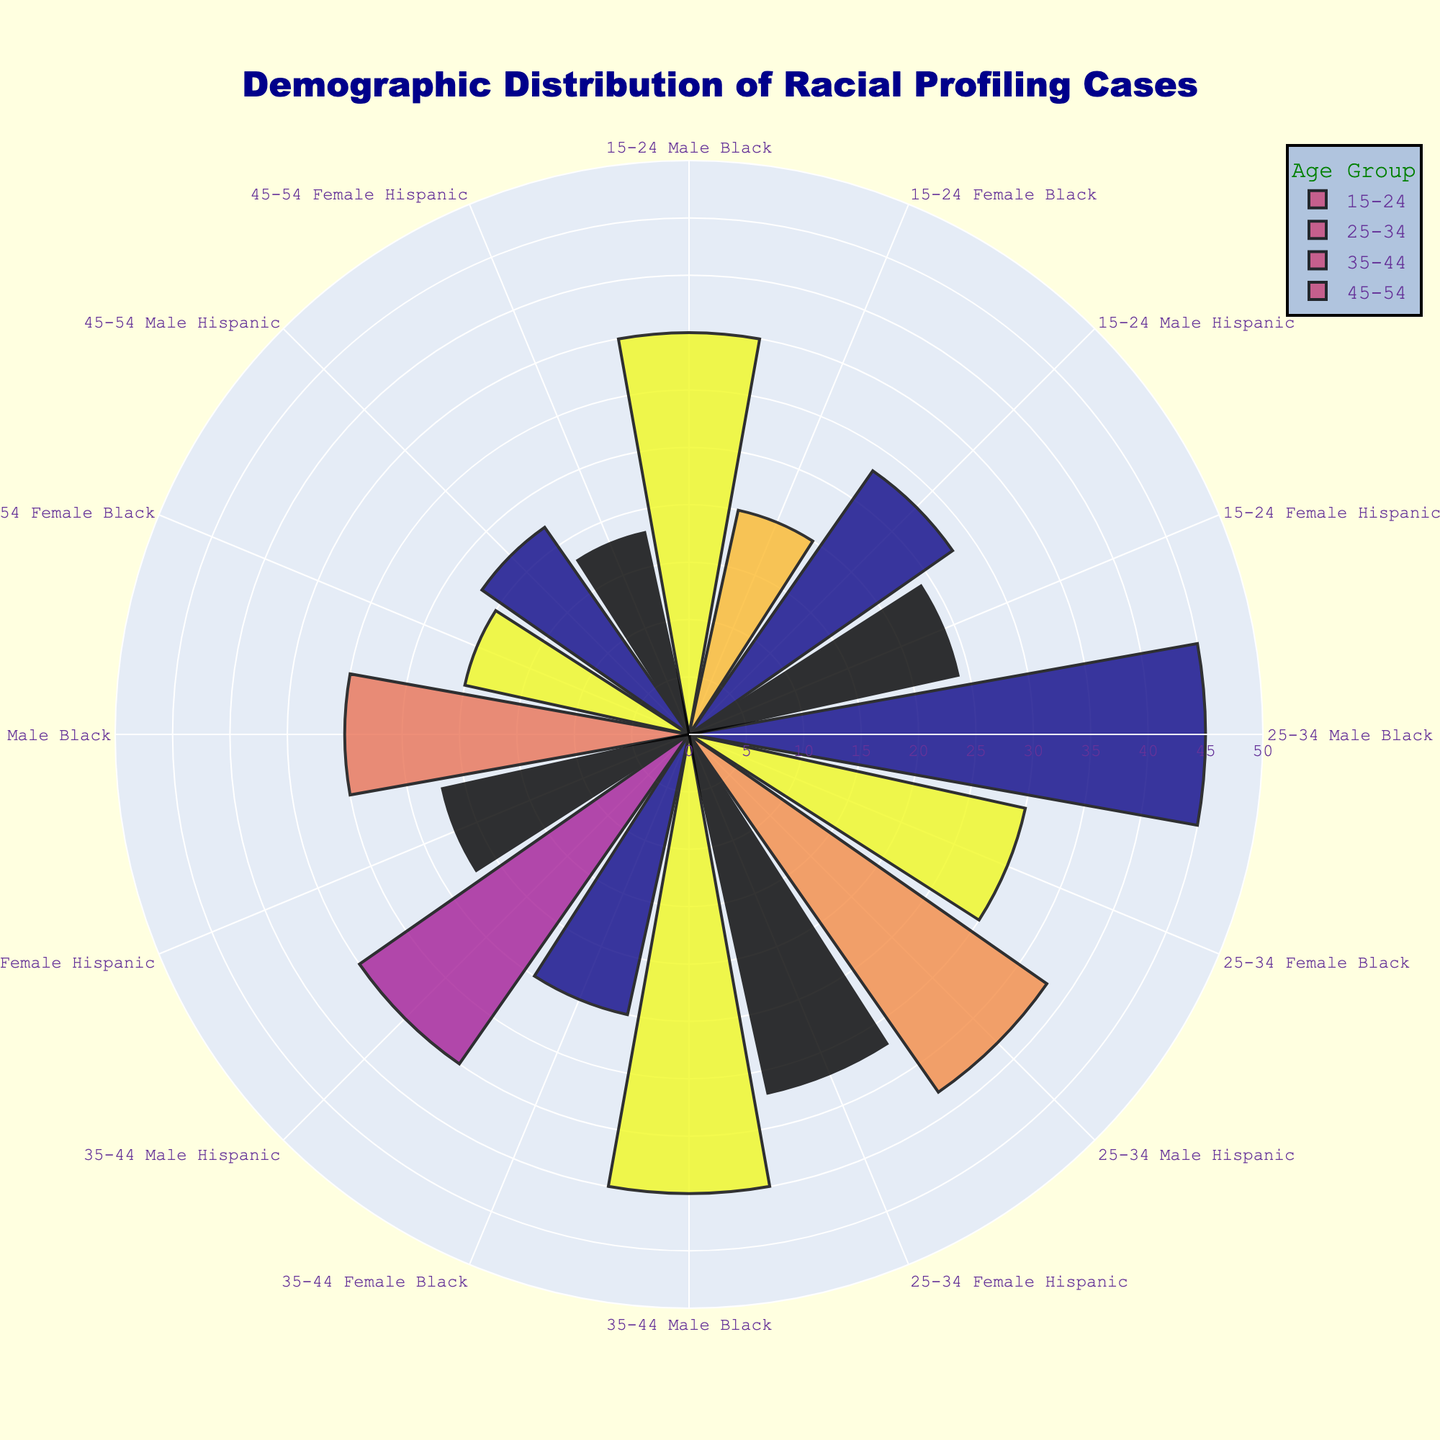What is the title of the chart? The title is located at the top of the figure. It is written to indicate what the chart is about.
Answer: Demographic Distribution of Racial Profiling Cases What is the highest number of reported cases in the age group 25-34? Look at the bars labeled with the 25-34 age group, find the largest radius which represents the highest number of reported cases.
Answer: 45 How many total reported cases are there for Hispanic females across all age groups? Add the reported cases numbers for Hispanic females in each age group: 24 (15-24) + 32 (25-34) + 22 (35-44) + 18 (45-54).
Answer: 96 Which ethnicity and gender in the age group 35-44 has the most reported cases? Look at the age group labeled 35-44 and identify the bar with the largest radius. Check its gender and ethnicity.
Answer: Black Males Compare the number of reported cases between Black and Hispanic males in the age group 45-54. Which group has fewer cases? Look at the bars under the age group 45-54, compare the radii of the bars for Black Males and Hispanic Males.
Answer: Hispanic Males What is the average number of reported cases for Black females across all age groups? Sum the reported cases for Black females in each age group and then divide by the number of age groups: (20 + 30 + 25 + 20) / 4.
Answer: 23.75 Which gender in the 15-24 age group has a higher total number of reported cases? Total the reported cases for males and females within the 15-24 age group: 35 (Male, Black) + 28 (Male, Hispanic) and 20 (Female, Black) + 24 (Female, Hispanic).
Answer: Males Is there a notable difference between the number of cases reported for Black males aged 25-34 and those aged 35-44? Compare the radii for Black males in the age groups 25-34 and 35-44 directly: look at the length of the bars.
Answer: Yes, it decreases from 45 to 40 Among all the groups, which has the lowest single case count and in which age group? Look for the smallest bar in the entire figure and identify the group and age.
Answer: 45-54 Hispanic Females 